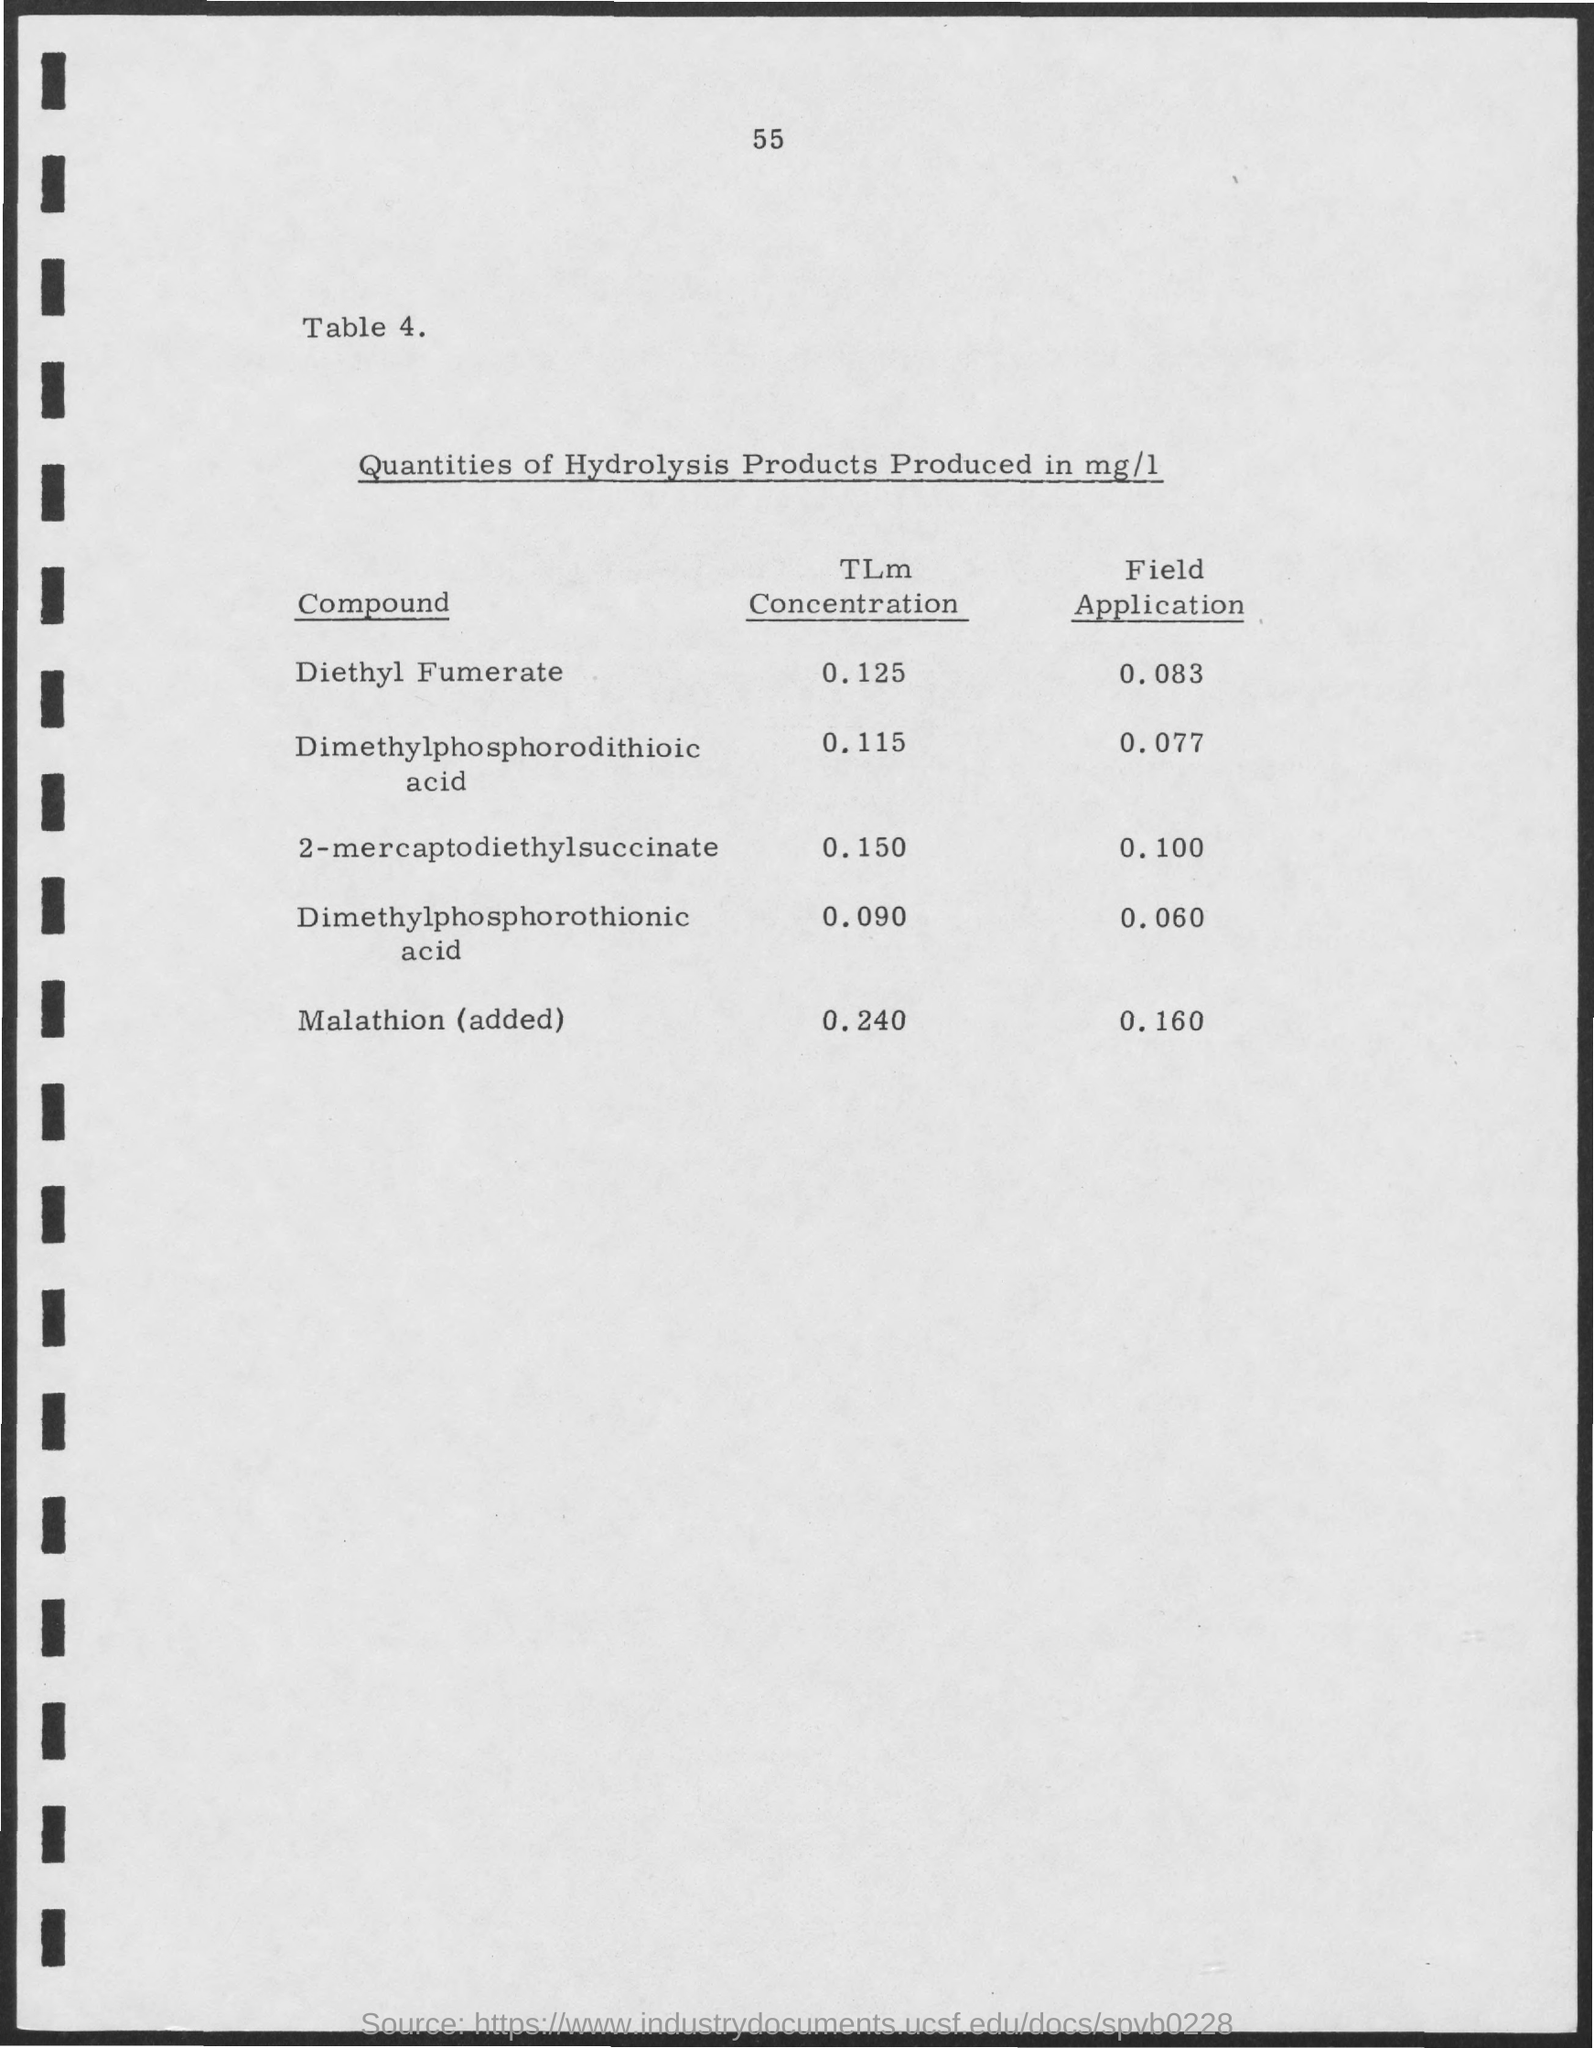Identify some key points in this picture. The diethyl fumerate TLm concentration is 0.125... The TLm concentration of malathion, after it has been added, is 0.240... The field application for dimethylphosphorodithioic acid is 0.077... The field application for Malathion is 0.160... The field application for 2-mercaptodiethylsuccinate is 0.100. 